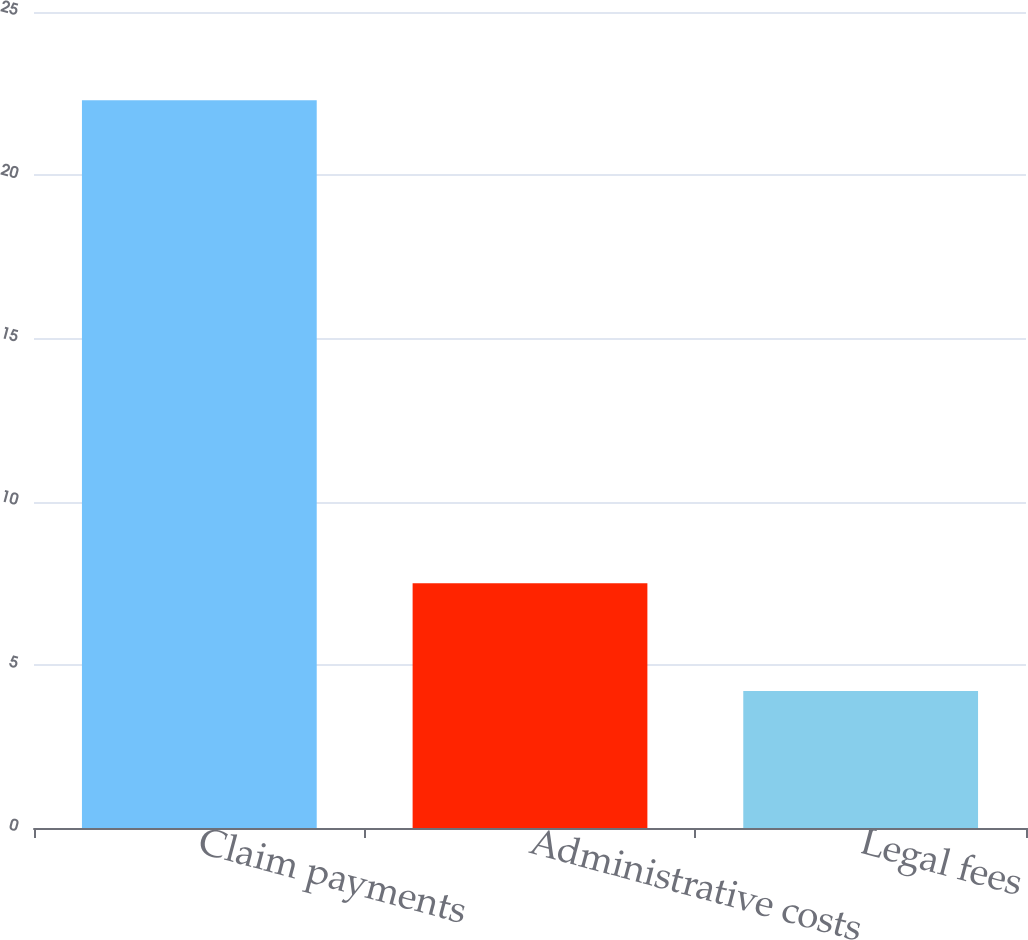<chart> <loc_0><loc_0><loc_500><loc_500><bar_chart><fcel>Claim payments<fcel>Administrative costs<fcel>Legal fees<nl><fcel>22.3<fcel>7.5<fcel>4.2<nl></chart> 